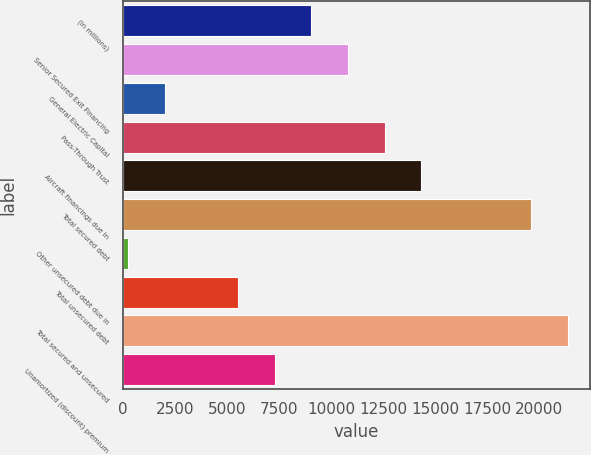<chart> <loc_0><loc_0><loc_500><loc_500><bar_chart><fcel>(in millions)<fcel>Senior Secured Exit Financing<fcel>General Electric Capital<fcel>Pass-Through Trust<fcel>Aircraft financings due in<fcel>Total secured debt<fcel>Other unsecured debt due in<fcel>Total unsecured debt<fcel>Total secured and unsecured<fcel>Unamortized (discount) premium<nl><fcel>9065<fcel>10825<fcel>2025<fcel>12585<fcel>14345<fcel>19625<fcel>265<fcel>5545<fcel>21385<fcel>7305<nl></chart> 